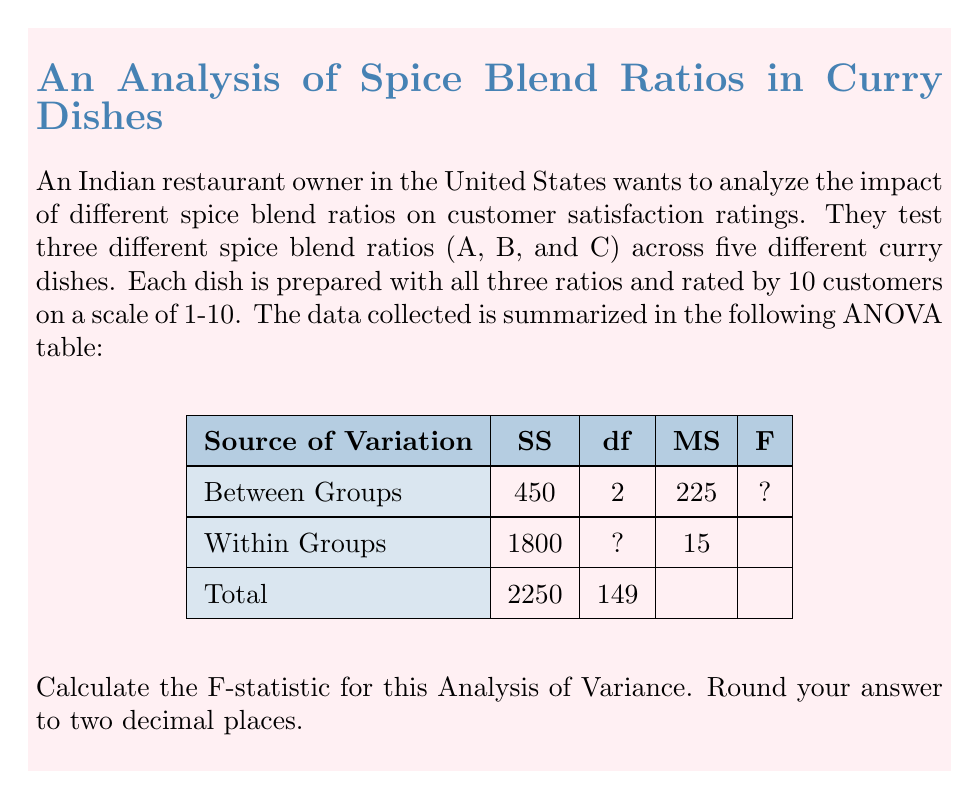Solve this math problem. To calculate the F-statistic, we need to follow these steps:

1. Identify the missing values in the ANOVA table:
   - We need to find the degrees of freedom (df) for "Within Groups"
   - We need to calculate the F-statistic

2. Calculate the missing df:
   - Total df = 149
   - Between Groups df = 2
   - Within Groups df = Total df - Between Groups df
   - Within Groups df = 149 - 2 = 147

3. Verify the Mean Square (MS) for Within Groups:
   - MS = SS / df
   - 15 = 1800 / 147 (This checks out)

4. Calculate the F-statistic:
   - F = MS (Between Groups) / MS (Within Groups)
   - F = 225 / 15 = 15

5. Round the F-statistic to two decimal places:
   - F ≈ 15.00

The F-statistic of 15.00 suggests that there is a significant difference between the spice blend ratios in terms of their impact on customer satisfaction ratings.
Answer: 15.00 